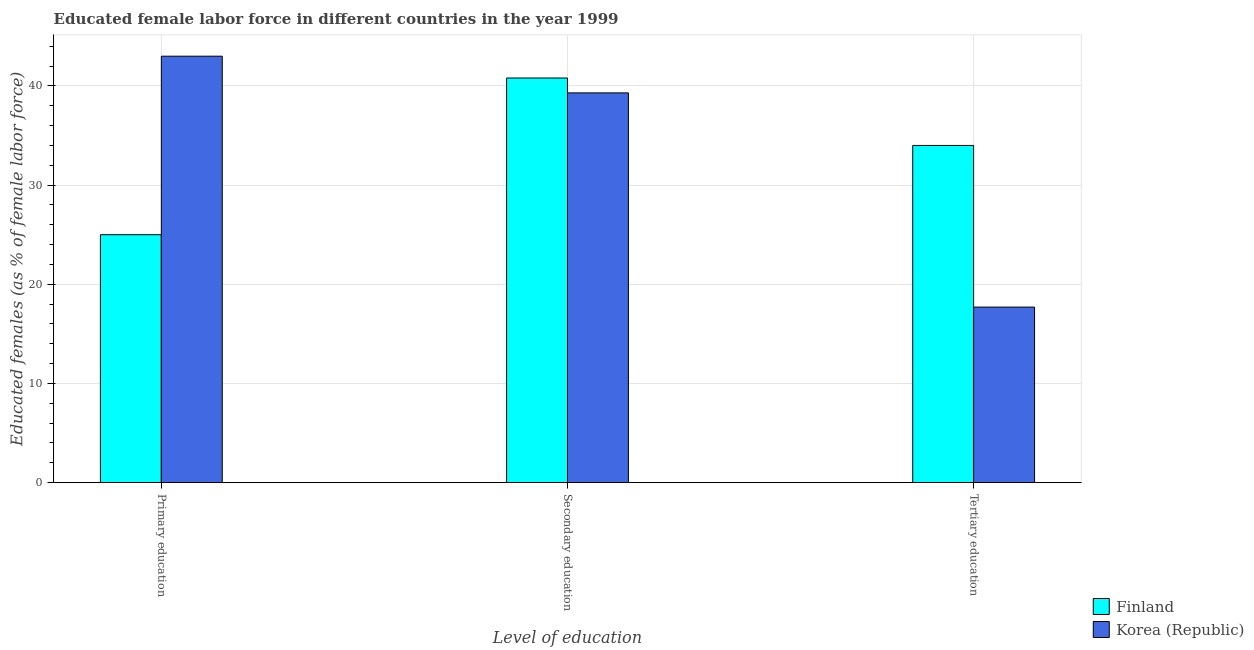Are the number of bars per tick equal to the number of legend labels?
Offer a terse response. Yes. Are the number of bars on each tick of the X-axis equal?
Keep it short and to the point. Yes. What is the label of the 1st group of bars from the left?
Your response must be concise. Primary education. Across all countries, what is the minimum percentage of female labor force who received primary education?
Your answer should be compact. 25. In which country was the percentage of female labor force who received tertiary education maximum?
Provide a short and direct response. Finland. What is the total percentage of female labor force who received tertiary education in the graph?
Your answer should be very brief. 51.7. What is the difference between the percentage of female labor force who received tertiary education in Finland and that in Korea (Republic)?
Offer a terse response. 16.3. What is the average percentage of female labor force who received tertiary education per country?
Give a very brief answer. 25.85. What is the difference between the percentage of female labor force who received secondary education and percentage of female labor force who received primary education in Korea (Republic)?
Offer a very short reply. -3.7. What is the ratio of the percentage of female labor force who received primary education in Finland to that in Korea (Republic)?
Keep it short and to the point. 0.58. What is the difference between the highest and the second highest percentage of female labor force who received tertiary education?
Make the answer very short. 16.3. Is the sum of the percentage of female labor force who received primary education in Finland and Korea (Republic) greater than the maximum percentage of female labor force who received secondary education across all countries?
Give a very brief answer. Yes. Are all the bars in the graph horizontal?
Give a very brief answer. No. Does the graph contain any zero values?
Offer a very short reply. No. Where does the legend appear in the graph?
Your answer should be compact. Bottom right. How many legend labels are there?
Your answer should be very brief. 2. How are the legend labels stacked?
Your answer should be compact. Vertical. What is the title of the graph?
Ensure brevity in your answer.  Educated female labor force in different countries in the year 1999. Does "Poland" appear as one of the legend labels in the graph?
Provide a short and direct response. No. What is the label or title of the X-axis?
Provide a short and direct response. Level of education. What is the label or title of the Y-axis?
Offer a terse response. Educated females (as % of female labor force). What is the Educated females (as % of female labor force) of Korea (Republic) in Primary education?
Provide a succinct answer. 43. What is the Educated females (as % of female labor force) in Finland in Secondary education?
Your answer should be compact. 40.8. What is the Educated females (as % of female labor force) of Korea (Republic) in Secondary education?
Your response must be concise. 39.3. What is the Educated females (as % of female labor force) of Korea (Republic) in Tertiary education?
Offer a very short reply. 17.7. Across all Level of education, what is the maximum Educated females (as % of female labor force) in Finland?
Provide a short and direct response. 40.8. Across all Level of education, what is the minimum Educated females (as % of female labor force) of Korea (Republic)?
Your answer should be very brief. 17.7. What is the total Educated females (as % of female labor force) of Finland in the graph?
Keep it short and to the point. 99.8. What is the total Educated females (as % of female labor force) of Korea (Republic) in the graph?
Keep it short and to the point. 100. What is the difference between the Educated females (as % of female labor force) of Finland in Primary education and that in Secondary education?
Your answer should be very brief. -15.8. What is the difference between the Educated females (as % of female labor force) in Korea (Republic) in Primary education and that in Secondary education?
Make the answer very short. 3.7. What is the difference between the Educated females (as % of female labor force) of Finland in Primary education and that in Tertiary education?
Keep it short and to the point. -9. What is the difference between the Educated females (as % of female labor force) in Korea (Republic) in Primary education and that in Tertiary education?
Offer a very short reply. 25.3. What is the difference between the Educated females (as % of female labor force) of Finland in Secondary education and that in Tertiary education?
Provide a succinct answer. 6.8. What is the difference between the Educated females (as % of female labor force) in Korea (Republic) in Secondary education and that in Tertiary education?
Offer a very short reply. 21.6. What is the difference between the Educated females (as % of female labor force) of Finland in Primary education and the Educated females (as % of female labor force) of Korea (Republic) in Secondary education?
Your answer should be very brief. -14.3. What is the difference between the Educated females (as % of female labor force) of Finland in Primary education and the Educated females (as % of female labor force) of Korea (Republic) in Tertiary education?
Provide a succinct answer. 7.3. What is the difference between the Educated females (as % of female labor force) in Finland in Secondary education and the Educated females (as % of female labor force) in Korea (Republic) in Tertiary education?
Offer a terse response. 23.1. What is the average Educated females (as % of female labor force) of Finland per Level of education?
Offer a very short reply. 33.27. What is the average Educated females (as % of female labor force) in Korea (Republic) per Level of education?
Offer a very short reply. 33.33. What is the difference between the Educated females (as % of female labor force) in Finland and Educated females (as % of female labor force) in Korea (Republic) in Primary education?
Make the answer very short. -18. What is the difference between the Educated females (as % of female labor force) in Finland and Educated females (as % of female labor force) in Korea (Republic) in Secondary education?
Your answer should be compact. 1.5. What is the difference between the Educated females (as % of female labor force) of Finland and Educated females (as % of female labor force) of Korea (Republic) in Tertiary education?
Offer a very short reply. 16.3. What is the ratio of the Educated females (as % of female labor force) in Finland in Primary education to that in Secondary education?
Your answer should be very brief. 0.61. What is the ratio of the Educated females (as % of female labor force) of Korea (Republic) in Primary education to that in Secondary education?
Keep it short and to the point. 1.09. What is the ratio of the Educated females (as % of female labor force) of Finland in Primary education to that in Tertiary education?
Provide a succinct answer. 0.74. What is the ratio of the Educated females (as % of female labor force) of Korea (Republic) in Primary education to that in Tertiary education?
Make the answer very short. 2.43. What is the ratio of the Educated females (as % of female labor force) of Korea (Republic) in Secondary education to that in Tertiary education?
Your answer should be very brief. 2.22. What is the difference between the highest and the second highest Educated females (as % of female labor force) of Finland?
Offer a very short reply. 6.8. What is the difference between the highest and the second highest Educated females (as % of female labor force) of Korea (Republic)?
Give a very brief answer. 3.7. What is the difference between the highest and the lowest Educated females (as % of female labor force) of Korea (Republic)?
Provide a succinct answer. 25.3. 